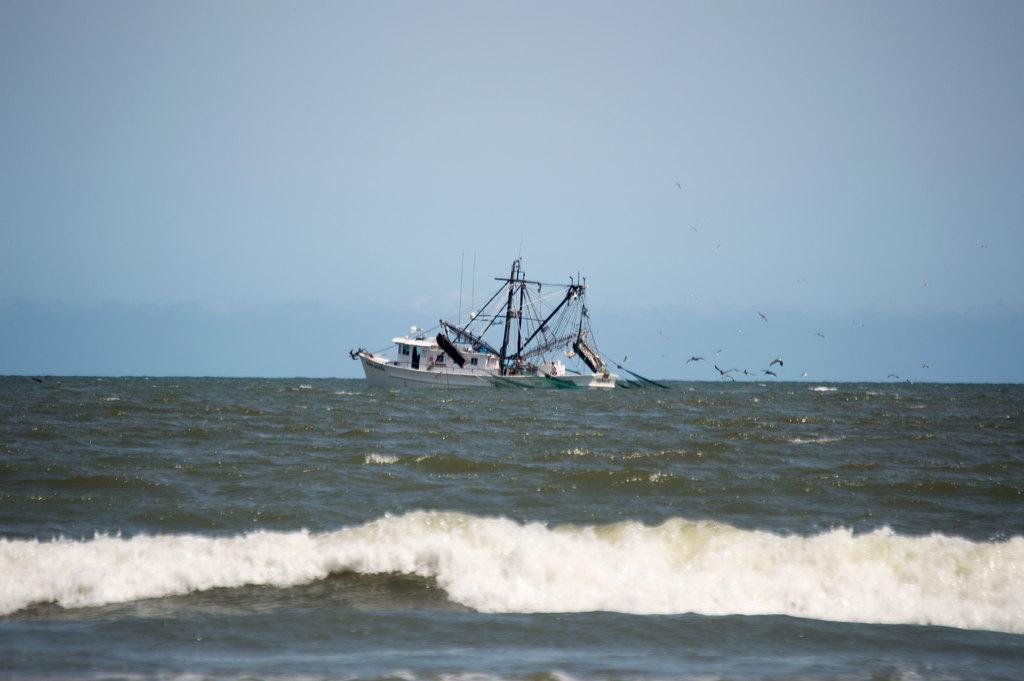What is the main subject of the image? The main subject of the image is a boat. Where is the boat located in the image? The boat is on the water. What can be seen in the background of the image? There is sky visible in the background of the image. What type of table is visible in the image? There is no table present in the image; it features a boat on the water. What question is being asked by the boat in the image? The boat is not asking any question in the image; it is simply floating on the water. 